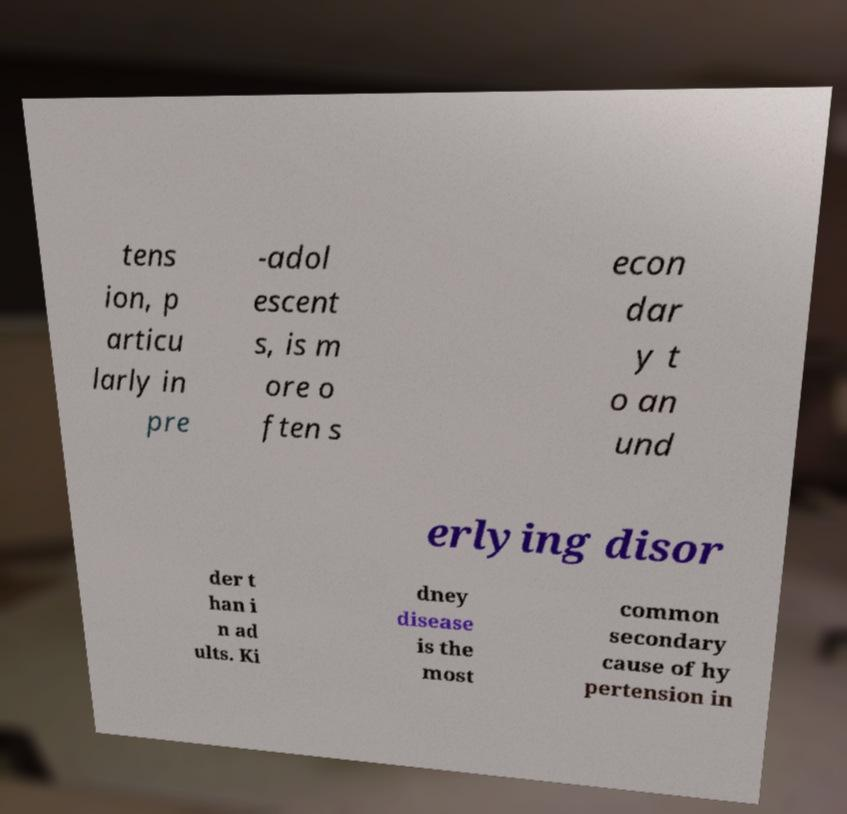Could you assist in decoding the text presented in this image and type it out clearly? tens ion, p articu larly in pre -adol escent s, is m ore o ften s econ dar y t o an und erlying disor der t han i n ad ults. Ki dney disease is the most common secondary cause of hy pertension in 